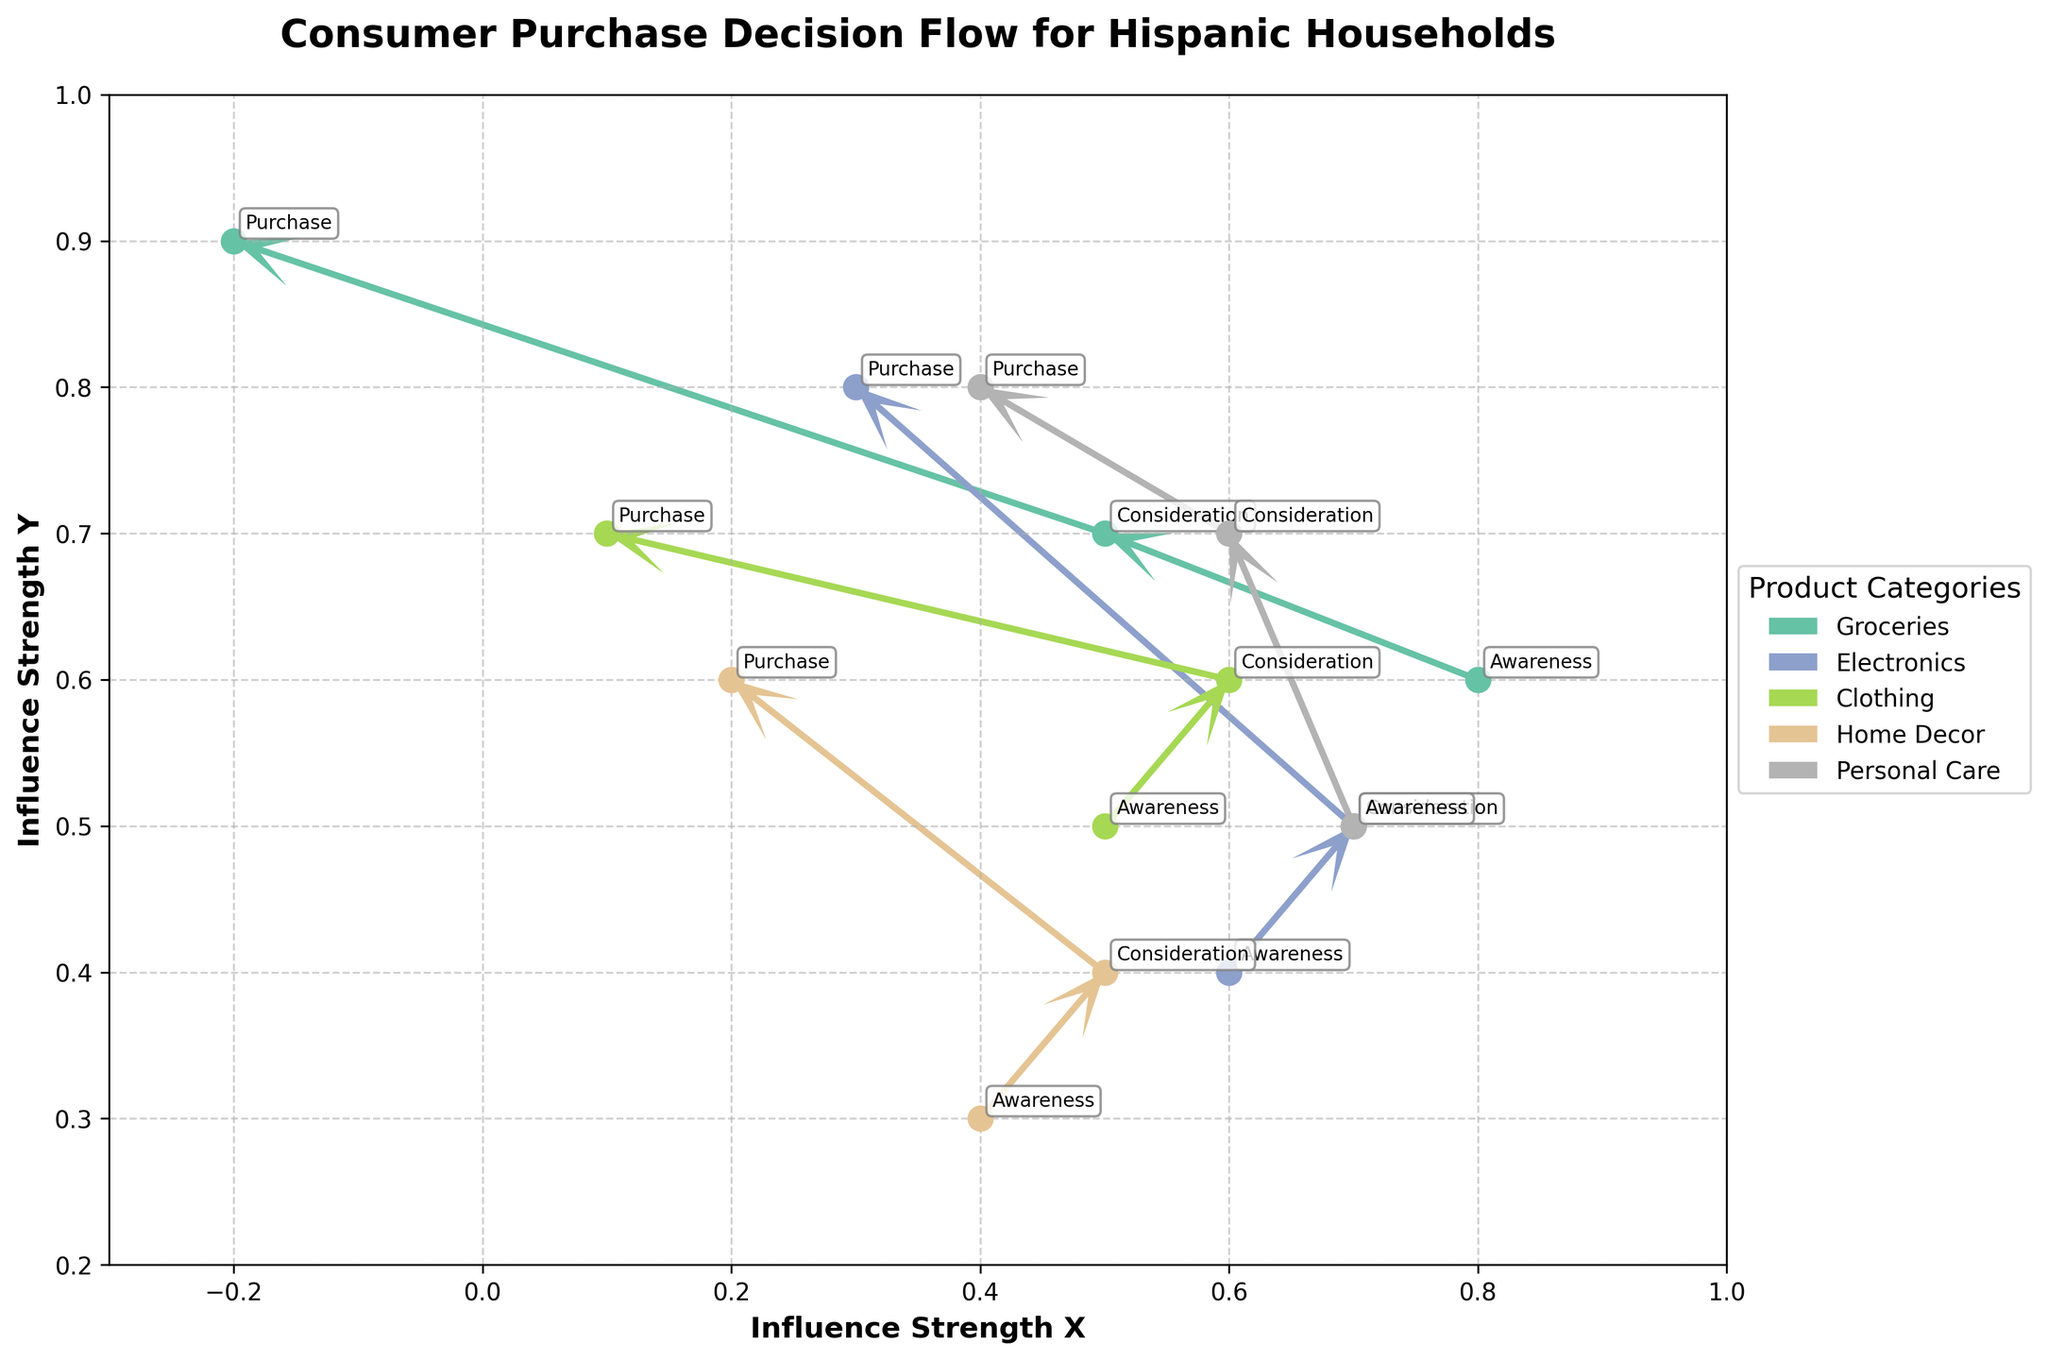What is the title of the plot? The title is typically located at the top of the plot. For this figure, it reads "Consumer Purchase Decision Flow for Hispanic Households".
Answer: Consumer Purchase Decision Flow for Hispanic Households Which product category has the strongest purchase influence in the Y-axis? By examining the Y-axis positions of the Purchase stage across different product categories, Personal Care has the highest value at Y = 0.8.
Answer: Personal Care How many product categories are analyzed in the figure? The legend on the right-hand side of the plot lists the distinct product categories. There are five product categories: Groceries, Electronics, Clothing, Home Decor, and Personal Care.
Answer: 5 What are the influence strengths (X, Y) for the Consideration stage of Home Decor? Locate the points on the plot for Home Decor (they will be the same color). Then find the label for the Consideration stage. The coordinates for this point are approximately (0.5, 0.4).
Answer: (0.5, 0.4) Which product category has increasing influence strengths in both X and Y from Awareness to Purchase? Follow the arrows from Awareness to Purchase for each category. Personal Care has increasing influence strengths in both X and Y directions across all stages (from 0.7 to 0.4 in X and from 0.5 to 0.8 in Y).
Answer: Personal Care What is the color used for the Groceries category in the plot? Refer to the legend to identify the color associated with Groceries. It uses a specific color which is different for each category. Groceries is shown in pink.
Answer: Pink Which product category transitions from a positive to a negative influence in the X axis from Consideration to Purchase? Identify the direction of the arrows from Consideration to Purchase for each category. Groceries has this transition with a decrease in X from 0.5 to -0.2.
Answer: Groceries What is the difference in Y-axis influence strength between Purchase stages of Groceries and Electronics? Find the Y-axis values for the Purchase stages of both categories. Groceries has a value of 0.9, Electronics has a value of 0.8. The difference is 0.9 - 0.8.
Answer: 0.1 Compare the influence strength in the X direction at the Awareness stage between Electronics and Home Decor. Which is greater? Look at the X values for Awareness in both categories. Electronics has an X value of 0.6, while Home Decor has an X value of 0.4, so Electronics is greater.
Answer: Electronics How does the influence in the Y-axis for Groceries change from Consideration to Purchase? Observe the Y values for the Consideration and Purchase points for Groceries. Consideration has a Y of 0.7 and Purchase has a Y of 0.9, showing an increase of 0.2.
Answer: Increases 